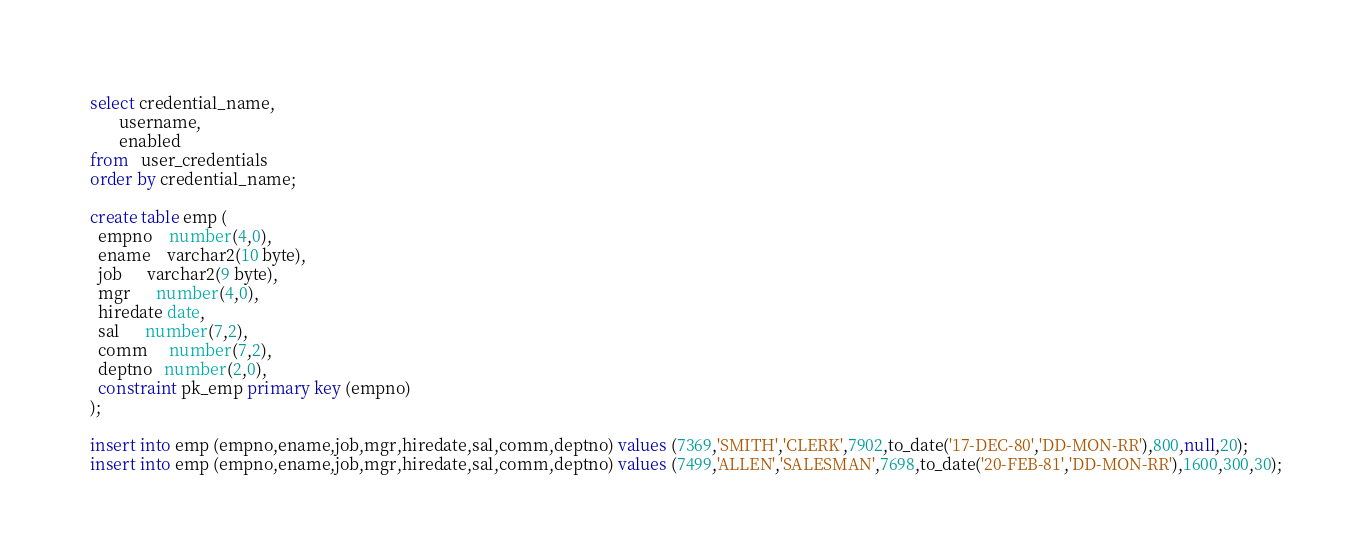<code> <loc_0><loc_0><loc_500><loc_500><_SQL_>select credential_name,
       username,
       enabled
from   user_credentials
order by credential_name;

create table emp (
  empno    number(4,0), 
  ename    varchar2(10 byte), 
  job      varchar2(9 byte), 
  mgr      number(4,0), 
  hiredate date, 
  sal      number(7,2), 
  comm     number(7,2), 
  deptno   number(2,0), 
  constraint pk_emp primary key (empno)
);
  
insert into emp (empno,ename,job,mgr,hiredate,sal,comm,deptno) values (7369,'SMITH','CLERK',7902,to_date('17-DEC-80','DD-MON-RR'),800,null,20);
insert into emp (empno,ename,job,mgr,hiredate,sal,comm,deptno) values (7499,'ALLEN','SALESMAN',7698,to_date('20-FEB-81','DD-MON-RR'),1600,300,30);</code> 